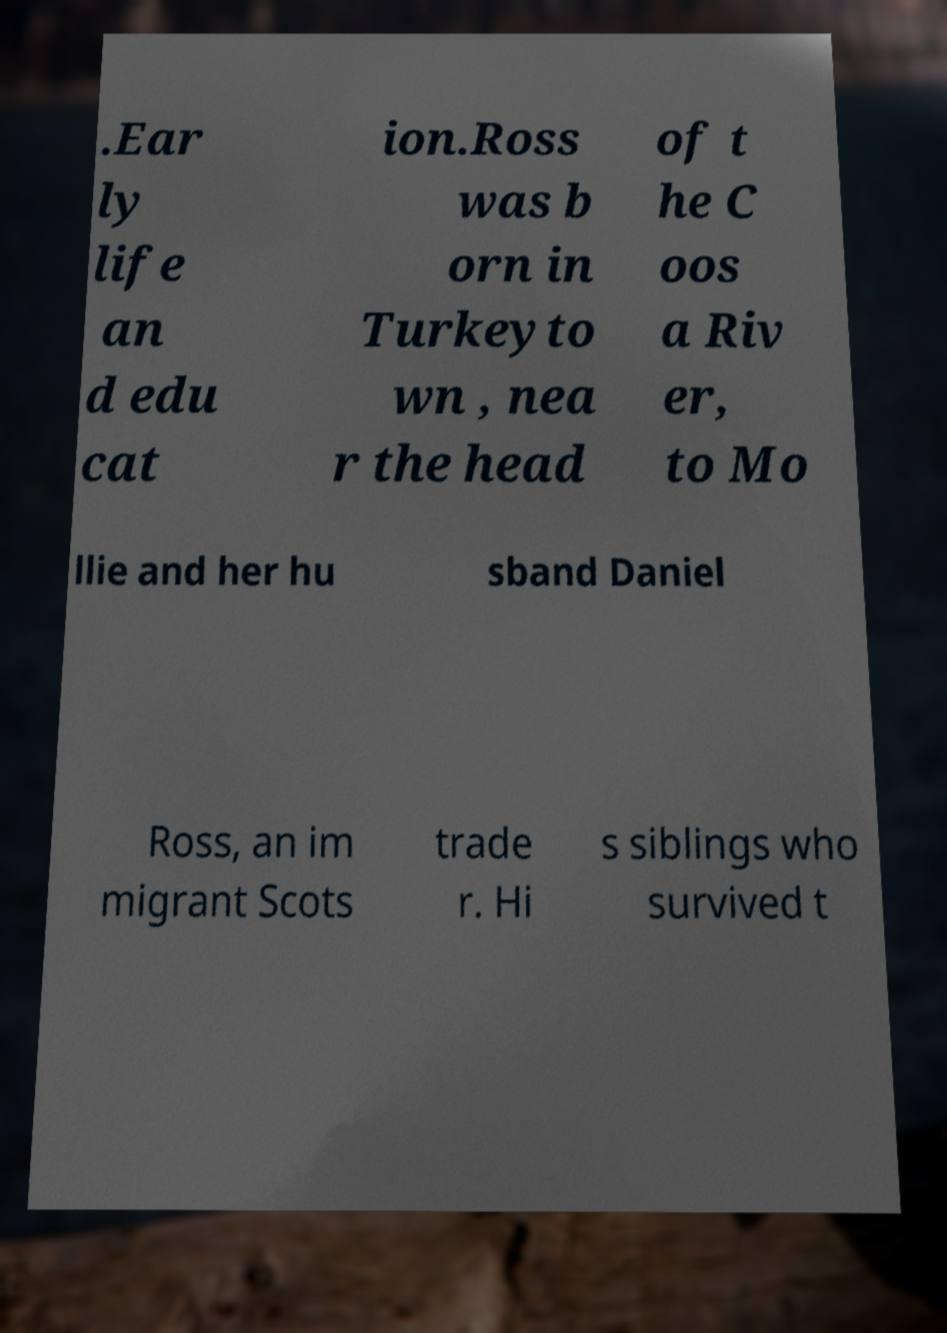Can you accurately transcribe the text from the provided image for me? .Ear ly life an d edu cat ion.Ross was b orn in Turkeyto wn , nea r the head of t he C oos a Riv er, to Mo llie and her hu sband Daniel Ross, an im migrant Scots trade r. Hi s siblings who survived t 